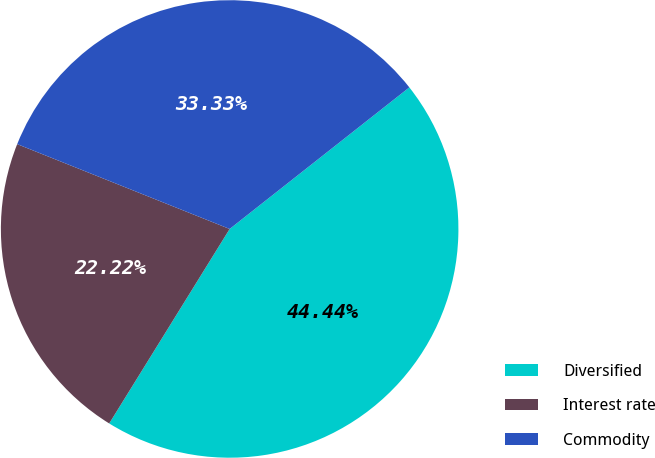Convert chart. <chart><loc_0><loc_0><loc_500><loc_500><pie_chart><fcel>Diversified<fcel>Interest rate<fcel>Commodity<nl><fcel>44.44%<fcel>22.22%<fcel>33.33%<nl></chart> 